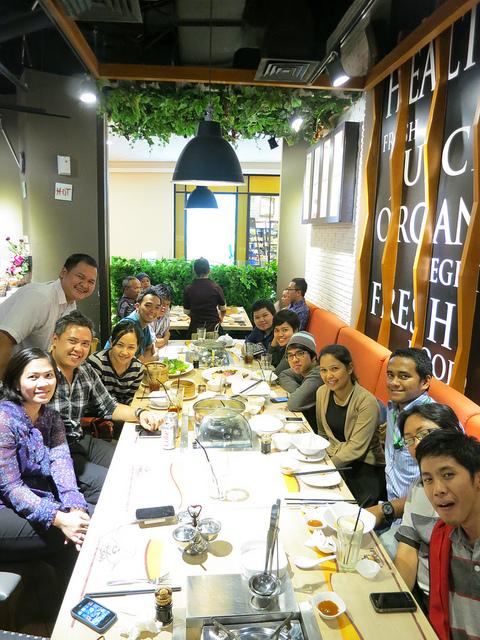How many people?
Write a very short answer. 16. Are the people on the right sitting in chairs or booths?
Write a very short answer. Booths. Is this a party?
Concise answer only. Yes. Is this someone's home?
Short answer required. No. 